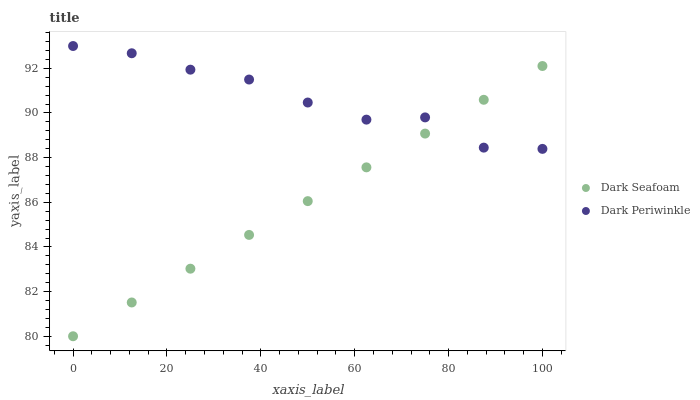Does Dark Seafoam have the minimum area under the curve?
Answer yes or no. Yes. Does Dark Periwinkle have the maximum area under the curve?
Answer yes or no. Yes. Does Dark Periwinkle have the minimum area under the curve?
Answer yes or no. No. Is Dark Seafoam the smoothest?
Answer yes or no. Yes. Is Dark Periwinkle the roughest?
Answer yes or no. Yes. Is Dark Periwinkle the smoothest?
Answer yes or no. No. Does Dark Seafoam have the lowest value?
Answer yes or no. Yes. Does Dark Periwinkle have the lowest value?
Answer yes or no. No. Does Dark Periwinkle have the highest value?
Answer yes or no. Yes. Does Dark Seafoam intersect Dark Periwinkle?
Answer yes or no. Yes. Is Dark Seafoam less than Dark Periwinkle?
Answer yes or no. No. Is Dark Seafoam greater than Dark Periwinkle?
Answer yes or no. No. 